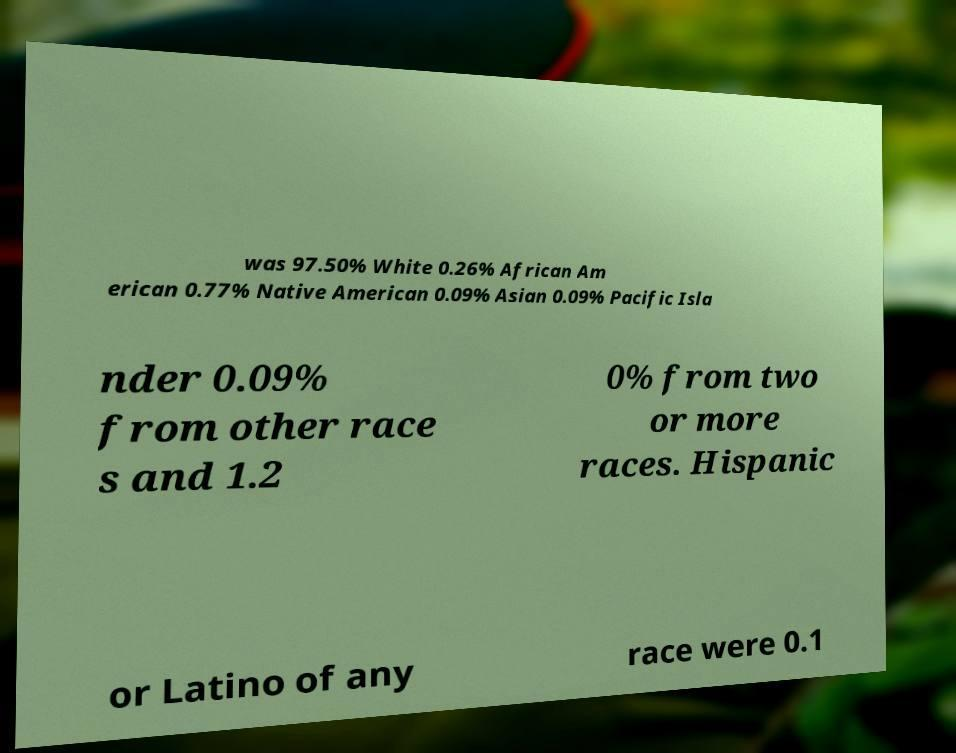What messages or text are displayed in this image? I need them in a readable, typed format. was 97.50% White 0.26% African Am erican 0.77% Native American 0.09% Asian 0.09% Pacific Isla nder 0.09% from other race s and 1.2 0% from two or more races. Hispanic or Latino of any race were 0.1 